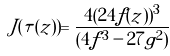<formula> <loc_0><loc_0><loc_500><loc_500>J ( \tau ( z ) ) = \frac { 4 ( 2 4 f ( z ) ) ^ { 3 } } { ( 4 f ^ { 3 } - 2 7 g ^ { 2 } ) }</formula> 